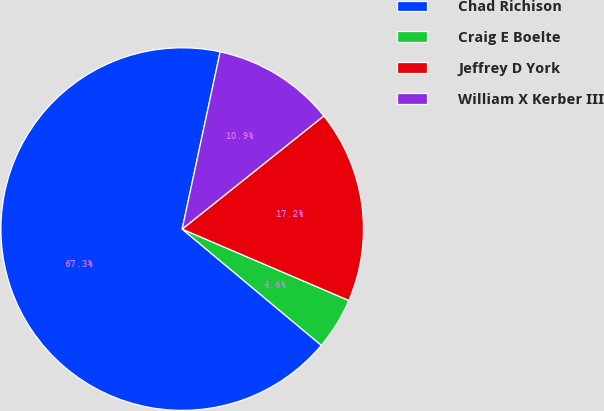Convert chart to OTSL. <chart><loc_0><loc_0><loc_500><loc_500><pie_chart><fcel>Chad Richison<fcel>Craig E Boelte<fcel>Jeffrey D York<fcel>William X Kerber III<nl><fcel>67.28%<fcel>4.64%<fcel>17.17%<fcel>10.91%<nl></chart> 